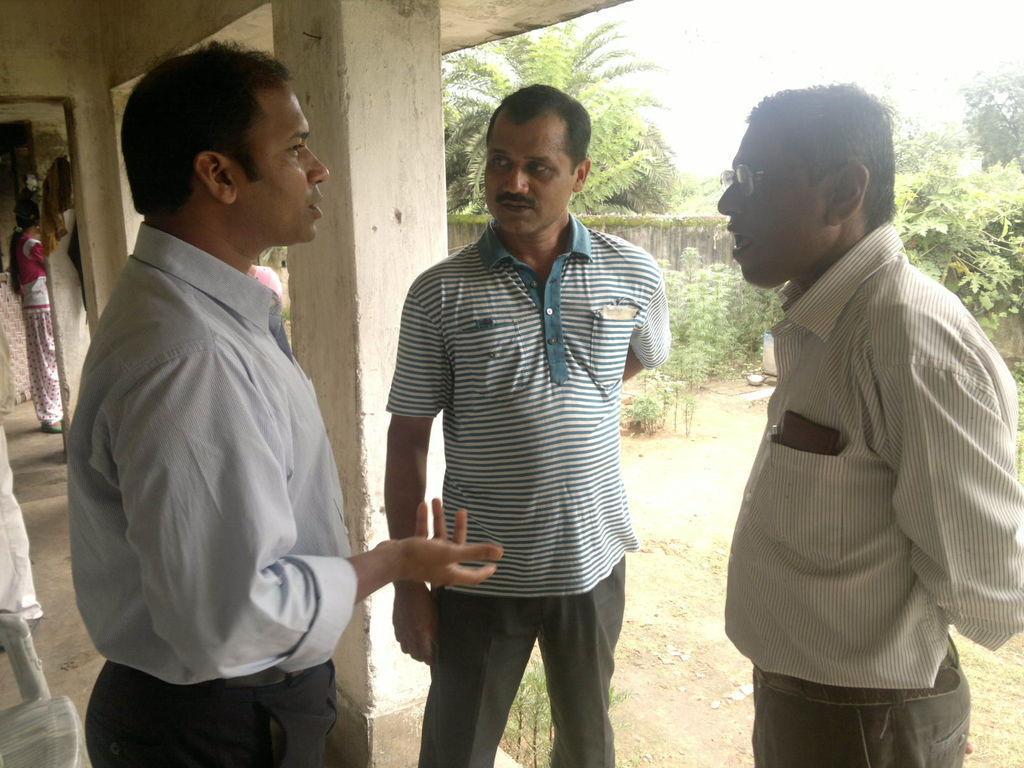Describe this image in one or two sentences. In the foreground of the image there are three persons standing. In the background of the image there are trees. There is wall. 